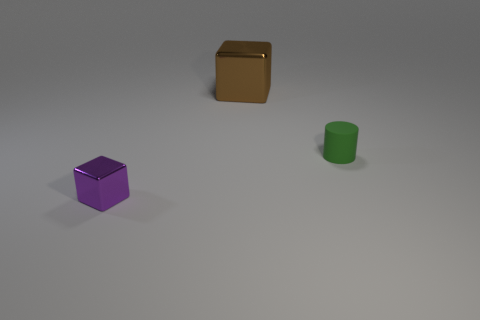Subtract all cyan blocks. Subtract all purple cylinders. How many blocks are left? 2 Add 3 tiny metallic things. How many objects exist? 6 Subtract all cylinders. How many objects are left? 2 Add 1 tiny objects. How many tiny objects exist? 3 Subtract 0 purple cylinders. How many objects are left? 3 Subtract all brown metallic cubes. Subtract all small green things. How many objects are left? 1 Add 3 brown cubes. How many brown cubes are left? 4 